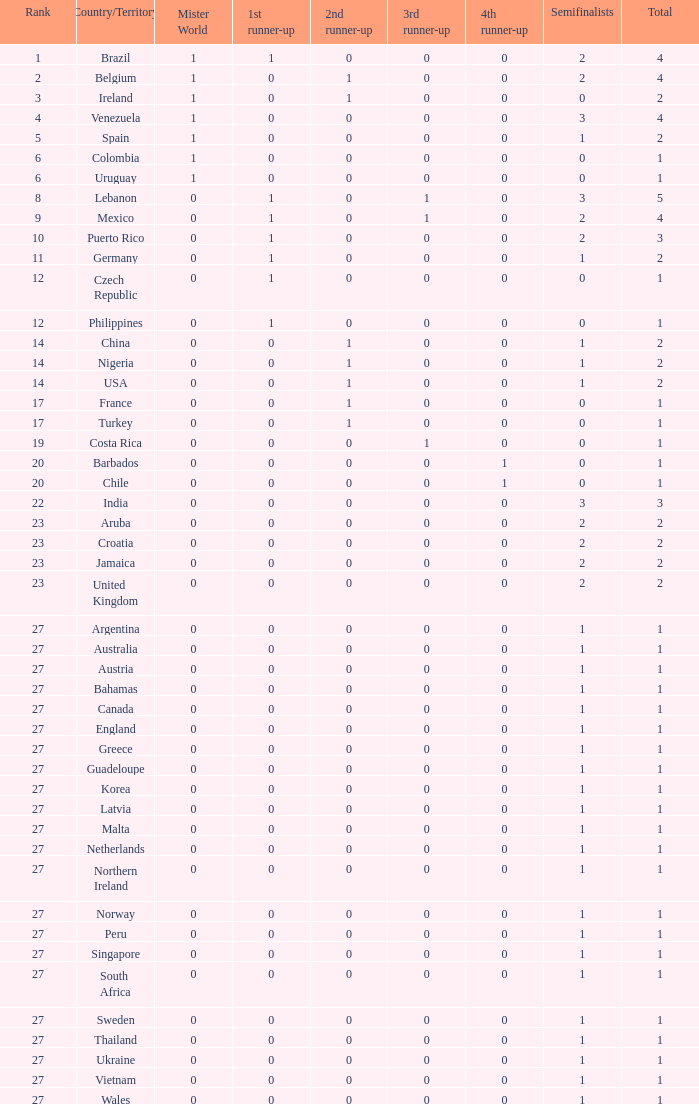What is the smallest 1st runner up value? 0.0. 